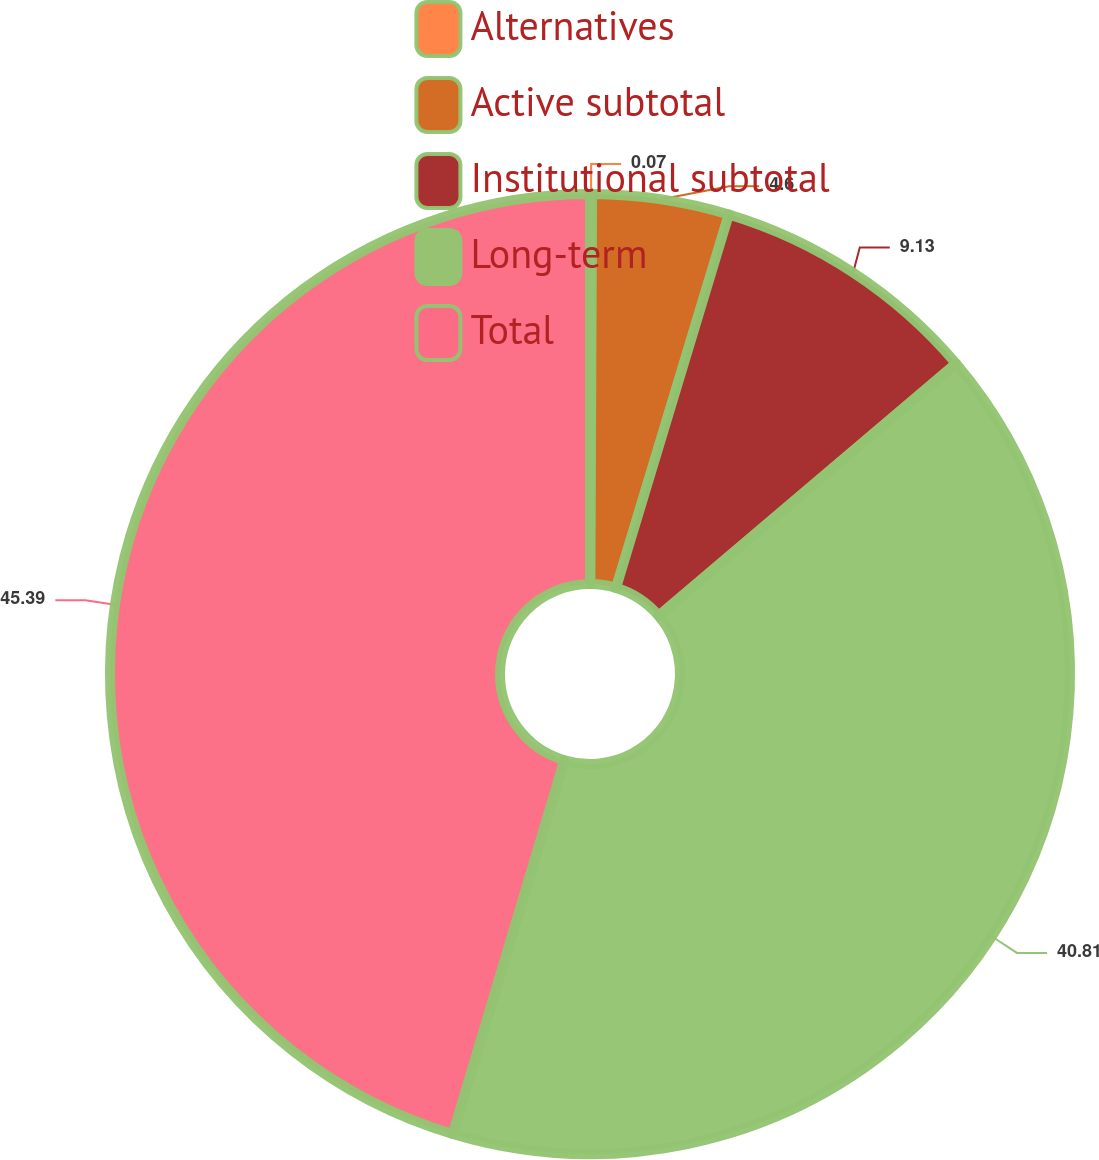Convert chart to OTSL. <chart><loc_0><loc_0><loc_500><loc_500><pie_chart><fcel>Alternatives<fcel>Active subtotal<fcel>Institutional subtotal<fcel>Long-term<fcel>Total<nl><fcel>0.07%<fcel>4.6%<fcel>9.13%<fcel>40.81%<fcel>45.38%<nl></chart> 